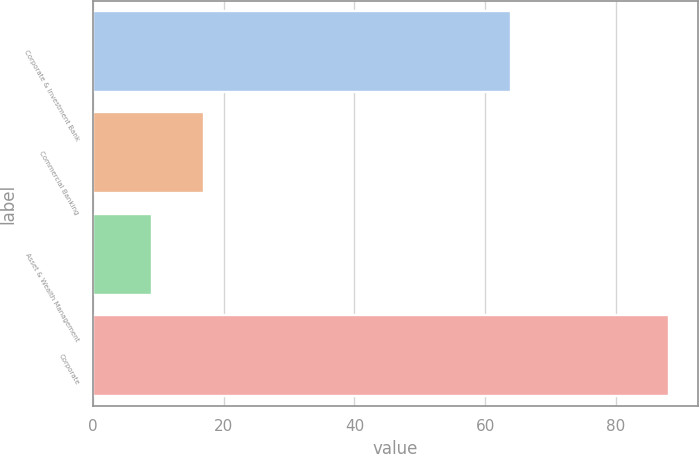Convert chart to OTSL. <chart><loc_0><loc_0><loc_500><loc_500><bar_chart><fcel>Corporate & Investment Bank<fcel>Commercial Banking<fcel>Asset & Wealth Management<fcel>Corporate<nl><fcel>64<fcel>16.91<fcel>9<fcel>88.1<nl></chart> 